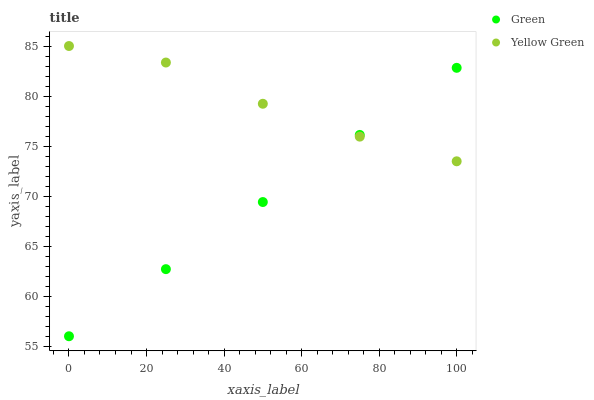Does Green have the minimum area under the curve?
Answer yes or no. Yes. Does Yellow Green have the maximum area under the curve?
Answer yes or no. Yes. Does Yellow Green have the minimum area under the curve?
Answer yes or no. No. Is Green the smoothest?
Answer yes or no. Yes. Is Yellow Green the roughest?
Answer yes or no. Yes. Is Yellow Green the smoothest?
Answer yes or no. No. Does Green have the lowest value?
Answer yes or no. Yes. Does Yellow Green have the lowest value?
Answer yes or no. No. Does Yellow Green have the highest value?
Answer yes or no. Yes. Does Yellow Green intersect Green?
Answer yes or no. Yes. Is Yellow Green less than Green?
Answer yes or no. No. Is Yellow Green greater than Green?
Answer yes or no. No. 